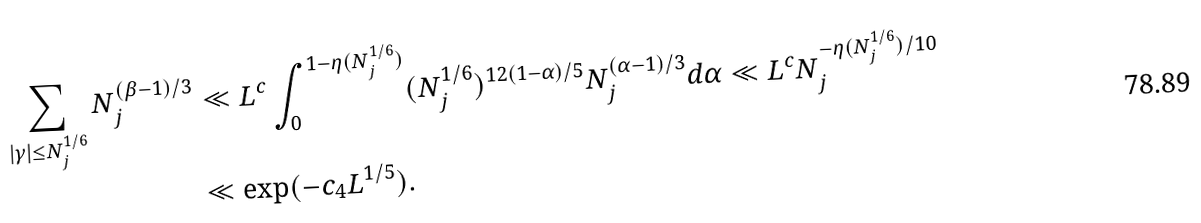<formula> <loc_0><loc_0><loc_500><loc_500>\sum _ { | \gamma | \leq N _ { j } ^ { 1 / 6 } } N _ { j } ^ { ( \beta - 1 ) / 3 } & \ll L ^ { c } \int _ { 0 } ^ { 1 - \eta ( N _ { j } ^ { 1 / 6 } ) } ( N _ { j } ^ { 1 / 6 } ) ^ { 1 2 ( 1 - \alpha ) / 5 } N _ { j } ^ { ( \alpha - 1 ) / 3 } d \alpha \ll L ^ { c } N _ { j } ^ { - \eta ( N _ { j } ^ { 1 / 6 } ) / 1 0 } \\ & \ll \exp ( - c _ { 4 } L ^ { 1 / 5 } ) .</formula> 